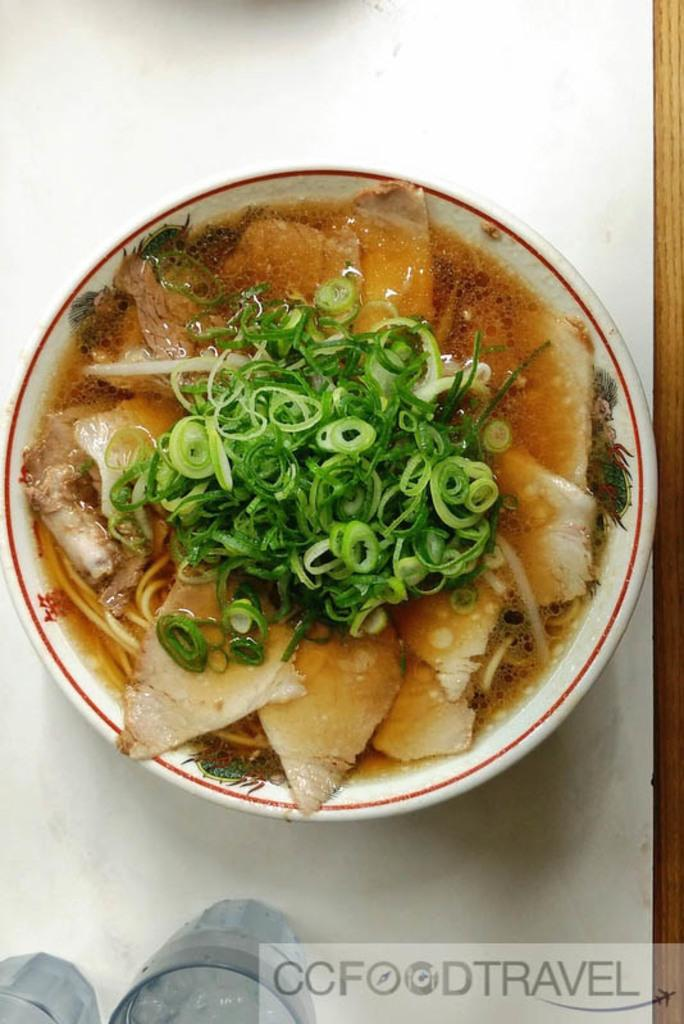What is in the bowl that is visible in the image? There is food in a bowl in the image. What is the color or material of the surface the bowl is on? The bowl is on a white surface. What else can be seen in the image besides the bowl of food? There are glasses visible in the image. Where is the text located in the image? The text is in the bottom right of the image. Can you see any toes in the image? There are no toes visible in the image. Is there a collar on any of the glasses in the image? There are no collars on the glasses in the image, as glasses do not have collars. 